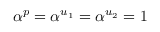<formula> <loc_0><loc_0><loc_500><loc_500>\alpha ^ { p } = \alpha ^ { u _ { 1 } } = \alpha ^ { u _ { 2 } } = 1</formula> 